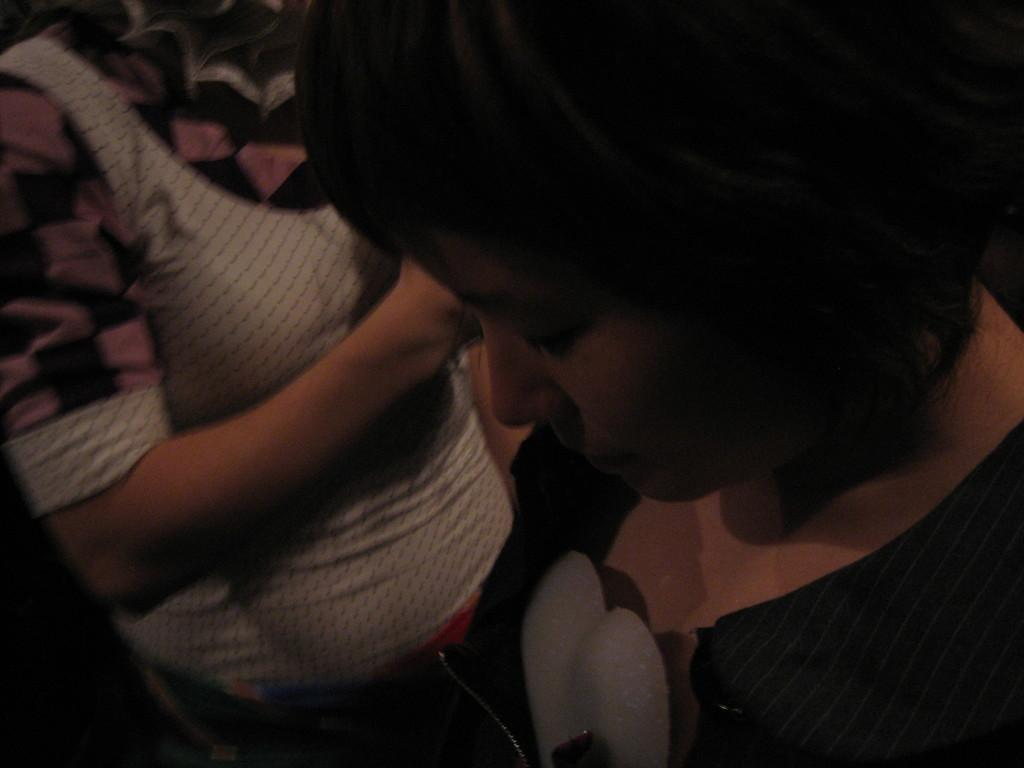Who is the main subject in the foreground of the image? There is a woman in the foreground of the image. Can you describe the person in the background of the image? The person in the background of the image is standing. How many people are present in the image? There are two people in the image, one in the foreground and one in the background. What type of bucket can be seen in the store in the image? There is no bucket or store present in the image; it features a woman in the foreground and another person in the background. 